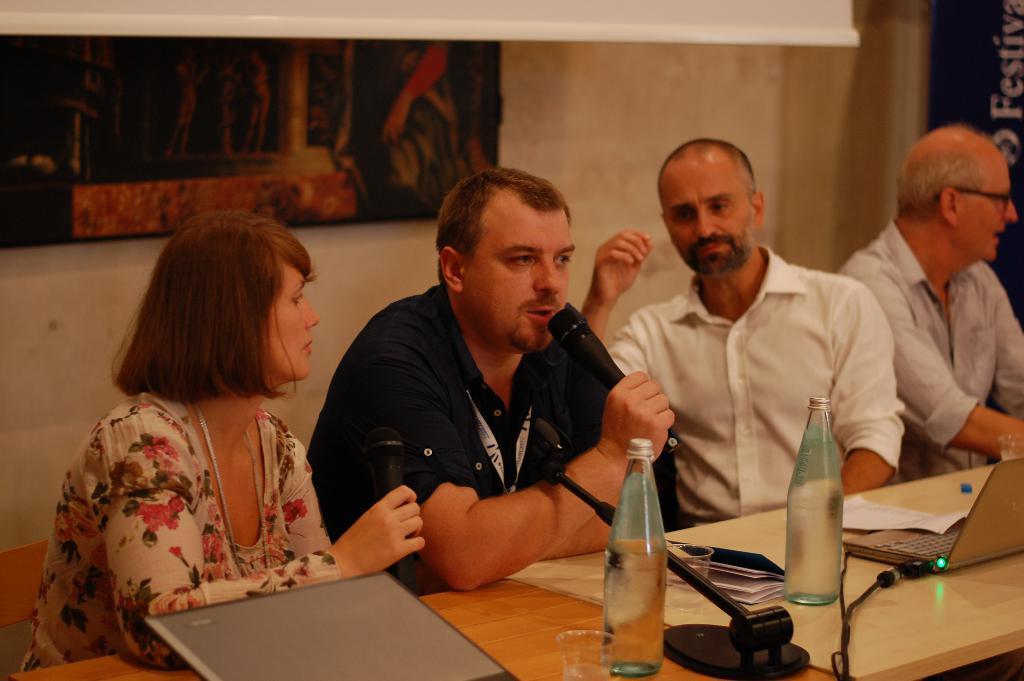Can you describe this image briefly? In this picture there are group of people, those who are sitting in front of the table, there is a bottles, books, and and laptops on the table, the lady who is left side of the image is holding a mice in her hand and a man who is sitting beside the lady is saying something in the mice, there is a portrait on the wall back side of the people. 